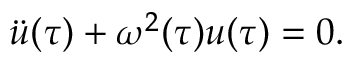<formula> <loc_0><loc_0><loc_500><loc_500>\ddot { u } ( \tau ) + \omega ^ { 2 } ( \tau ) { u } ( \tau ) = 0 .</formula> 